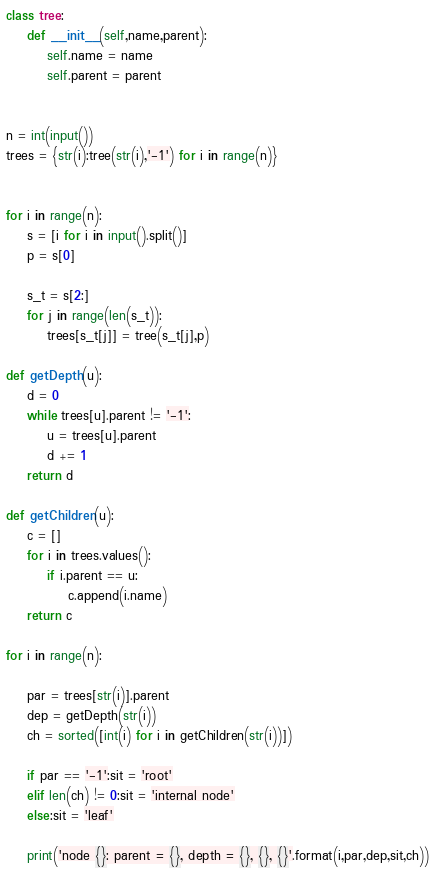Convert code to text. <code><loc_0><loc_0><loc_500><loc_500><_Python_>class tree:
    def __init__(self,name,parent):
        self.name = name
        self.parent = parent
        
        
n = int(input())
trees = {str(i):tree(str(i),'-1') for i in range(n)}


for i in range(n):
    s = [i for i in input().split()]
    p = s[0]

    s_t = s[2:]
    for j in range(len(s_t)):
        trees[s_t[j]] = tree(s_t[j],p)

def getDepth(u):
    d = 0
    while trees[u].parent != '-1':
        u = trees[u].parent
        d += 1
    return d

def getChildren(u):
    c = []
    for i in trees.values():
        if i.parent == u:
            c.append(i.name)
    return c

for i in range(n):
    
    par = trees[str(i)].parent
    dep = getDepth(str(i))
    ch = sorted([int(i) for i in getChildren(str(i))])
    
    if par == '-1':sit = 'root'
    elif len(ch) != 0:sit = 'internal node'
    else:sit = 'leaf'
    
    print('node {}: parent = {}, depth = {}, {}, {}'.format(i,par,dep,sit,ch))

</code> 